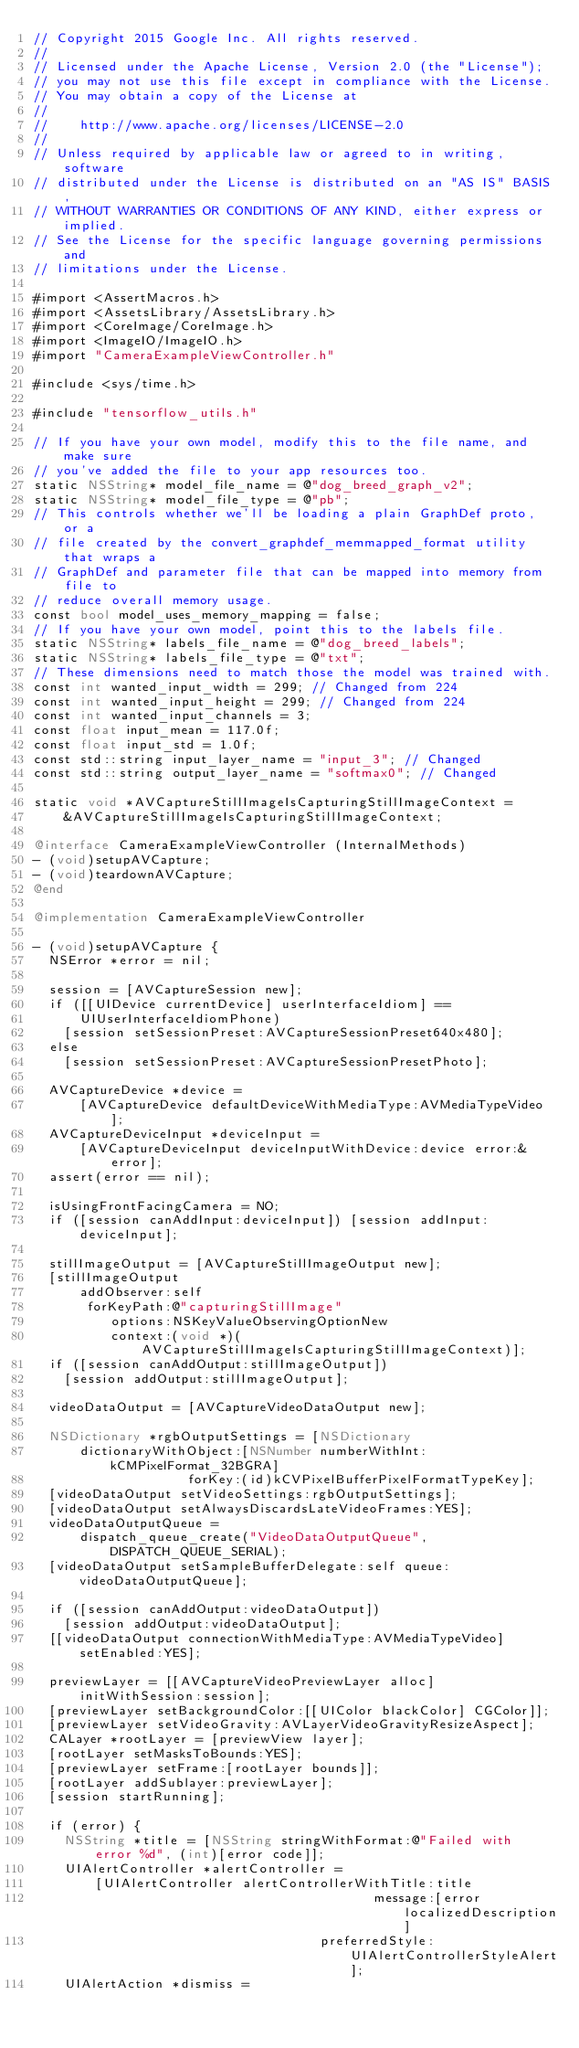<code> <loc_0><loc_0><loc_500><loc_500><_ObjectiveC_>// Copyright 2015 Google Inc. All rights reserved.
//
// Licensed under the Apache License, Version 2.0 (the "License");
// you may not use this file except in compliance with the License.
// You may obtain a copy of the License at
//
//    http://www.apache.org/licenses/LICENSE-2.0
//
// Unless required by applicable law or agreed to in writing, software
// distributed under the License is distributed on an "AS IS" BASIS,
// WITHOUT WARRANTIES OR CONDITIONS OF ANY KIND, either express or implied.
// See the License for the specific language governing permissions and
// limitations under the License.

#import <AssertMacros.h>
#import <AssetsLibrary/AssetsLibrary.h>
#import <CoreImage/CoreImage.h>
#import <ImageIO/ImageIO.h>
#import "CameraExampleViewController.h"

#include <sys/time.h>

#include "tensorflow_utils.h"

// If you have your own model, modify this to the file name, and make sure
// you've added the file to your app resources too.
static NSString* model_file_name = @"dog_breed_graph_v2";
static NSString* model_file_type = @"pb";
// This controls whether we'll be loading a plain GraphDef proto, or a
// file created by the convert_graphdef_memmapped_format utility that wraps a
// GraphDef and parameter file that can be mapped into memory from file to
// reduce overall memory usage.
const bool model_uses_memory_mapping = false;
// If you have your own model, point this to the labels file.
static NSString* labels_file_name = @"dog_breed_labels";
static NSString* labels_file_type = @"txt";
// These dimensions need to match those the model was trained with.
const int wanted_input_width = 299; // Changed from 224
const int wanted_input_height = 299; // Changed from 224
const int wanted_input_channels = 3;
const float input_mean = 117.0f;
const float input_std = 1.0f;
const std::string input_layer_name = "input_3"; // Changed
const std::string output_layer_name = "softmax0"; // Changed

static void *AVCaptureStillImageIsCapturingStillImageContext =
    &AVCaptureStillImageIsCapturingStillImageContext;

@interface CameraExampleViewController (InternalMethods)
- (void)setupAVCapture;
- (void)teardownAVCapture;
@end

@implementation CameraExampleViewController

- (void)setupAVCapture {
  NSError *error = nil;

  session = [AVCaptureSession new];
  if ([[UIDevice currentDevice] userInterfaceIdiom] ==
      UIUserInterfaceIdiomPhone)
    [session setSessionPreset:AVCaptureSessionPreset640x480];
  else
    [session setSessionPreset:AVCaptureSessionPresetPhoto];

  AVCaptureDevice *device =
      [AVCaptureDevice defaultDeviceWithMediaType:AVMediaTypeVideo];
  AVCaptureDeviceInput *deviceInput =
      [AVCaptureDeviceInput deviceInputWithDevice:device error:&error];
  assert(error == nil);

  isUsingFrontFacingCamera = NO;
  if ([session canAddInput:deviceInput]) [session addInput:deviceInput];

  stillImageOutput = [AVCaptureStillImageOutput new];
  [stillImageOutput
      addObserver:self
       forKeyPath:@"capturingStillImage"
          options:NSKeyValueObservingOptionNew
          context:(void *)(AVCaptureStillImageIsCapturingStillImageContext)];
  if ([session canAddOutput:stillImageOutput])
    [session addOutput:stillImageOutput];

  videoDataOutput = [AVCaptureVideoDataOutput new];

  NSDictionary *rgbOutputSettings = [NSDictionary
      dictionaryWithObject:[NSNumber numberWithInt:kCMPixelFormat_32BGRA]
                    forKey:(id)kCVPixelBufferPixelFormatTypeKey];
  [videoDataOutput setVideoSettings:rgbOutputSettings];
  [videoDataOutput setAlwaysDiscardsLateVideoFrames:YES];
  videoDataOutputQueue =
      dispatch_queue_create("VideoDataOutputQueue", DISPATCH_QUEUE_SERIAL);
  [videoDataOutput setSampleBufferDelegate:self queue:videoDataOutputQueue];

  if ([session canAddOutput:videoDataOutput])
    [session addOutput:videoDataOutput];
  [[videoDataOutput connectionWithMediaType:AVMediaTypeVideo] setEnabled:YES];

  previewLayer = [[AVCaptureVideoPreviewLayer alloc] initWithSession:session];
  [previewLayer setBackgroundColor:[[UIColor blackColor] CGColor]];
  [previewLayer setVideoGravity:AVLayerVideoGravityResizeAspect];
  CALayer *rootLayer = [previewView layer];
  [rootLayer setMasksToBounds:YES];
  [previewLayer setFrame:[rootLayer bounds]];
  [rootLayer addSublayer:previewLayer];
  [session startRunning];

  if (error) {
    NSString *title = [NSString stringWithFormat:@"Failed with error %d", (int)[error code]];
    UIAlertController *alertController =
        [UIAlertController alertControllerWithTitle:title
                                            message:[error localizedDescription]
                                     preferredStyle:UIAlertControllerStyleAlert];
    UIAlertAction *dismiss =</code> 